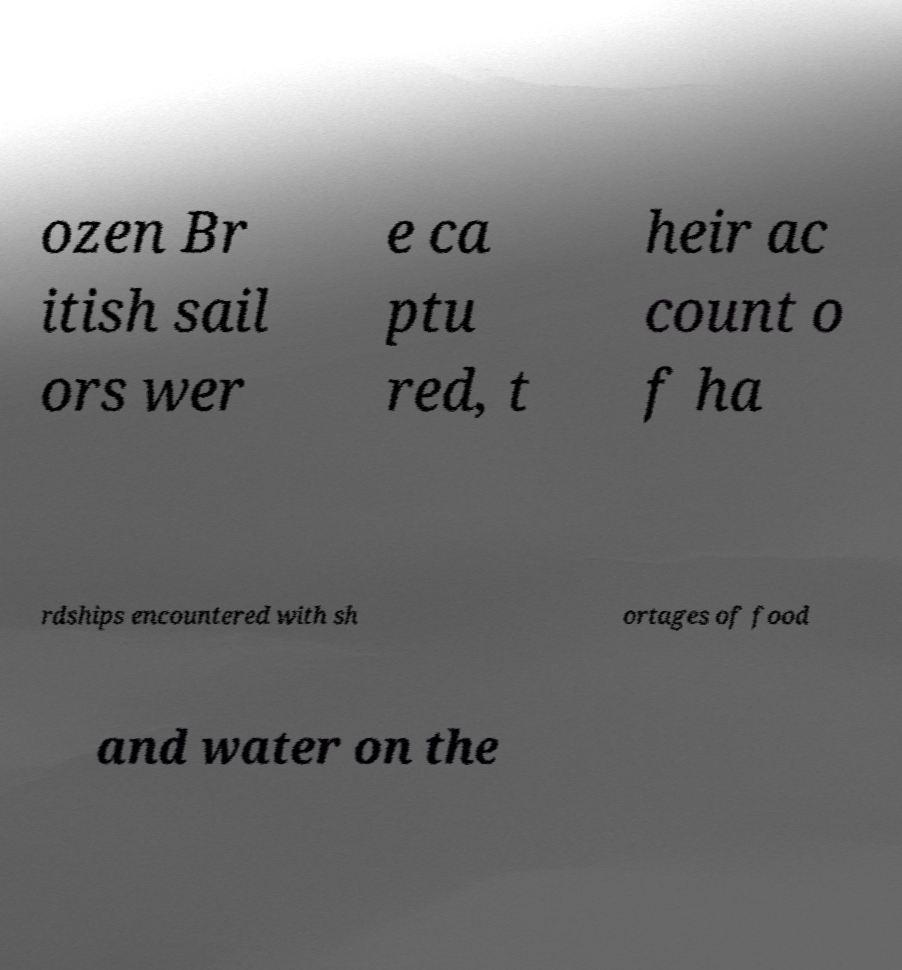Could you assist in decoding the text presented in this image and type it out clearly? ozen Br itish sail ors wer e ca ptu red, t heir ac count o f ha rdships encountered with sh ortages of food and water on the 